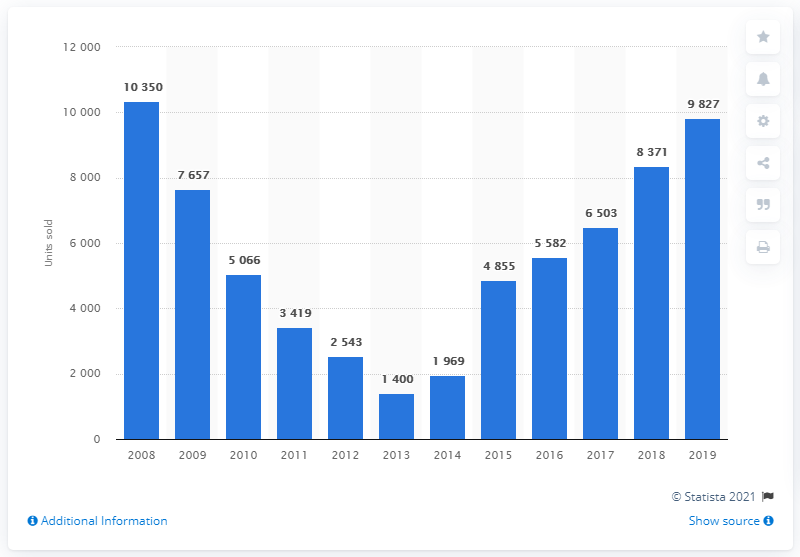Outline some significant characteristics in this image. In 2013, the number of cars sold in Greece was 1,400. In 2013, approximately 1,400 cars were sold in Greece. In 2019, a total of 9,827 units of Peugeot cars were sold in Greece. 